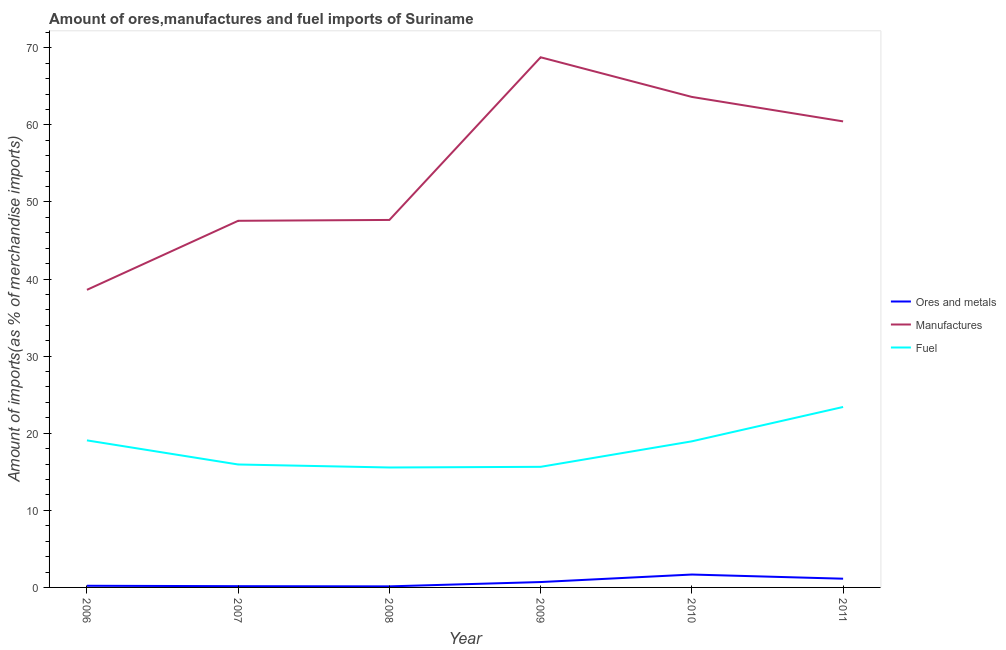Is the number of lines equal to the number of legend labels?
Ensure brevity in your answer.  Yes. What is the percentage of manufactures imports in 2006?
Your response must be concise. 38.6. Across all years, what is the maximum percentage of ores and metals imports?
Offer a very short reply. 1.67. Across all years, what is the minimum percentage of ores and metals imports?
Offer a very short reply. 0.14. In which year was the percentage of manufactures imports maximum?
Provide a succinct answer. 2009. What is the total percentage of ores and metals imports in the graph?
Provide a succinct answer. 4.02. What is the difference between the percentage of fuel imports in 2006 and that in 2007?
Offer a very short reply. 3.13. What is the difference between the percentage of manufactures imports in 2011 and the percentage of fuel imports in 2009?
Provide a succinct answer. 44.81. What is the average percentage of manufactures imports per year?
Your answer should be compact. 54.44. In the year 2009, what is the difference between the percentage of fuel imports and percentage of manufactures imports?
Make the answer very short. -53.12. What is the ratio of the percentage of fuel imports in 2007 to that in 2010?
Offer a terse response. 0.84. Is the percentage of manufactures imports in 2007 less than that in 2009?
Ensure brevity in your answer.  Yes. Is the difference between the percentage of ores and metals imports in 2007 and 2010 greater than the difference between the percentage of manufactures imports in 2007 and 2010?
Make the answer very short. Yes. What is the difference between the highest and the second highest percentage of manufactures imports?
Offer a very short reply. 5.14. What is the difference between the highest and the lowest percentage of ores and metals imports?
Keep it short and to the point. 1.54. In how many years, is the percentage of manufactures imports greater than the average percentage of manufactures imports taken over all years?
Ensure brevity in your answer.  3. Is the sum of the percentage of manufactures imports in 2009 and 2011 greater than the maximum percentage of fuel imports across all years?
Provide a short and direct response. Yes. Is it the case that in every year, the sum of the percentage of ores and metals imports and percentage of manufactures imports is greater than the percentage of fuel imports?
Give a very brief answer. Yes. Is the percentage of manufactures imports strictly greater than the percentage of ores and metals imports over the years?
Offer a terse response. Yes. How many lines are there?
Offer a very short reply. 3. Does the graph contain grids?
Provide a short and direct response. No. How many legend labels are there?
Your answer should be compact. 3. What is the title of the graph?
Ensure brevity in your answer.  Amount of ores,manufactures and fuel imports of Suriname. Does "Primary" appear as one of the legend labels in the graph?
Your answer should be compact. No. What is the label or title of the Y-axis?
Your answer should be very brief. Amount of imports(as % of merchandise imports). What is the Amount of imports(as % of merchandise imports) in Ores and metals in 2006?
Your answer should be very brief. 0.22. What is the Amount of imports(as % of merchandise imports) in Manufactures in 2006?
Ensure brevity in your answer.  38.6. What is the Amount of imports(as % of merchandise imports) of Fuel in 2006?
Your response must be concise. 19.07. What is the Amount of imports(as % of merchandise imports) of Ores and metals in 2007?
Ensure brevity in your answer.  0.16. What is the Amount of imports(as % of merchandise imports) in Manufactures in 2007?
Provide a succinct answer. 47.55. What is the Amount of imports(as % of merchandise imports) in Fuel in 2007?
Your response must be concise. 15.95. What is the Amount of imports(as % of merchandise imports) in Ores and metals in 2008?
Your answer should be very brief. 0.14. What is the Amount of imports(as % of merchandise imports) of Manufactures in 2008?
Your response must be concise. 47.67. What is the Amount of imports(as % of merchandise imports) in Fuel in 2008?
Give a very brief answer. 15.56. What is the Amount of imports(as % of merchandise imports) in Ores and metals in 2009?
Make the answer very short. 0.7. What is the Amount of imports(as % of merchandise imports) of Manufactures in 2009?
Your answer should be very brief. 68.76. What is the Amount of imports(as % of merchandise imports) of Fuel in 2009?
Your answer should be very brief. 15.64. What is the Amount of imports(as % of merchandise imports) of Ores and metals in 2010?
Make the answer very short. 1.67. What is the Amount of imports(as % of merchandise imports) of Manufactures in 2010?
Your answer should be very brief. 63.62. What is the Amount of imports(as % of merchandise imports) in Fuel in 2010?
Your answer should be very brief. 18.95. What is the Amount of imports(as % of merchandise imports) of Ores and metals in 2011?
Your response must be concise. 1.13. What is the Amount of imports(as % of merchandise imports) of Manufactures in 2011?
Your answer should be very brief. 60.45. What is the Amount of imports(as % of merchandise imports) of Fuel in 2011?
Your response must be concise. 23.4. Across all years, what is the maximum Amount of imports(as % of merchandise imports) in Ores and metals?
Ensure brevity in your answer.  1.67. Across all years, what is the maximum Amount of imports(as % of merchandise imports) of Manufactures?
Make the answer very short. 68.76. Across all years, what is the maximum Amount of imports(as % of merchandise imports) of Fuel?
Ensure brevity in your answer.  23.4. Across all years, what is the minimum Amount of imports(as % of merchandise imports) in Ores and metals?
Your answer should be very brief. 0.14. Across all years, what is the minimum Amount of imports(as % of merchandise imports) of Manufactures?
Make the answer very short. 38.6. Across all years, what is the minimum Amount of imports(as % of merchandise imports) of Fuel?
Ensure brevity in your answer.  15.56. What is the total Amount of imports(as % of merchandise imports) of Ores and metals in the graph?
Offer a very short reply. 4.02. What is the total Amount of imports(as % of merchandise imports) in Manufactures in the graph?
Your response must be concise. 326.65. What is the total Amount of imports(as % of merchandise imports) in Fuel in the graph?
Offer a terse response. 108.57. What is the difference between the Amount of imports(as % of merchandise imports) of Ores and metals in 2006 and that in 2007?
Provide a short and direct response. 0.05. What is the difference between the Amount of imports(as % of merchandise imports) in Manufactures in 2006 and that in 2007?
Keep it short and to the point. -8.95. What is the difference between the Amount of imports(as % of merchandise imports) of Fuel in 2006 and that in 2007?
Your response must be concise. 3.13. What is the difference between the Amount of imports(as % of merchandise imports) of Ores and metals in 2006 and that in 2008?
Your answer should be very brief. 0.08. What is the difference between the Amount of imports(as % of merchandise imports) in Manufactures in 2006 and that in 2008?
Give a very brief answer. -9.07. What is the difference between the Amount of imports(as % of merchandise imports) of Fuel in 2006 and that in 2008?
Make the answer very short. 3.52. What is the difference between the Amount of imports(as % of merchandise imports) of Ores and metals in 2006 and that in 2009?
Offer a terse response. -0.48. What is the difference between the Amount of imports(as % of merchandise imports) in Manufactures in 2006 and that in 2009?
Ensure brevity in your answer.  -30.16. What is the difference between the Amount of imports(as % of merchandise imports) in Fuel in 2006 and that in 2009?
Offer a very short reply. 3.43. What is the difference between the Amount of imports(as % of merchandise imports) in Ores and metals in 2006 and that in 2010?
Make the answer very short. -1.46. What is the difference between the Amount of imports(as % of merchandise imports) of Manufactures in 2006 and that in 2010?
Your response must be concise. -25.02. What is the difference between the Amount of imports(as % of merchandise imports) in Fuel in 2006 and that in 2010?
Your answer should be compact. 0.12. What is the difference between the Amount of imports(as % of merchandise imports) in Ores and metals in 2006 and that in 2011?
Your response must be concise. -0.91. What is the difference between the Amount of imports(as % of merchandise imports) of Manufactures in 2006 and that in 2011?
Your answer should be compact. -21.85. What is the difference between the Amount of imports(as % of merchandise imports) in Fuel in 2006 and that in 2011?
Provide a succinct answer. -4.33. What is the difference between the Amount of imports(as % of merchandise imports) of Ores and metals in 2007 and that in 2008?
Your response must be concise. 0.03. What is the difference between the Amount of imports(as % of merchandise imports) of Manufactures in 2007 and that in 2008?
Offer a very short reply. -0.11. What is the difference between the Amount of imports(as % of merchandise imports) of Fuel in 2007 and that in 2008?
Provide a short and direct response. 0.39. What is the difference between the Amount of imports(as % of merchandise imports) of Ores and metals in 2007 and that in 2009?
Provide a succinct answer. -0.53. What is the difference between the Amount of imports(as % of merchandise imports) of Manufactures in 2007 and that in 2009?
Provide a short and direct response. -21.21. What is the difference between the Amount of imports(as % of merchandise imports) in Fuel in 2007 and that in 2009?
Provide a short and direct response. 0.3. What is the difference between the Amount of imports(as % of merchandise imports) of Ores and metals in 2007 and that in 2010?
Provide a short and direct response. -1.51. What is the difference between the Amount of imports(as % of merchandise imports) in Manufactures in 2007 and that in 2010?
Offer a terse response. -16.07. What is the difference between the Amount of imports(as % of merchandise imports) in Fuel in 2007 and that in 2010?
Offer a terse response. -3. What is the difference between the Amount of imports(as % of merchandise imports) of Ores and metals in 2007 and that in 2011?
Offer a very short reply. -0.97. What is the difference between the Amount of imports(as % of merchandise imports) of Manufactures in 2007 and that in 2011?
Your answer should be very brief. -12.89. What is the difference between the Amount of imports(as % of merchandise imports) of Fuel in 2007 and that in 2011?
Provide a short and direct response. -7.46. What is the difference between the Amount of imports(as % of merchandise imports) in Ores and metals in 2008 and that in 2009?
Ensure brevity in your answer.  -0.56. What is the difference between the Amount of imports(as % of merchandise imports) in Manufactures in 2008 and that in 2009?
Ensure brevity in your answer.  -21.1. What is the difference between the Amount of imports(as % of merchandise imports) of Fuel in 2008 and that in 2009?
Ensure brevity in your answer.  -0.09. What is the difference between the Amount of imports(as % of merchandise imports) of Ores and metals in 2008 and that in 2010?
Provide a short and direct response. -1.54. What is the difference between the Amount of imports(as % of merchandise imports) in Manufactures in 2008 and that in 2010?
Offer a terse response. -15.96. What is the difference between the Amount of imports(as % of merchandise imports) of Fuel in 2008 and that in 2010?
Your response must be concise. -3.39. What is the difference between the Amount of imports(as % of merchandise imports) in Ores and metals in 2008 and that in 2011?
Provide a short and direct response. -0.99. What is the difference between the Amount of imports(as % of merchandise imports) of Manufactures in 2008 and that in 2011?
Make the answer very short. -12.78. What is the difference between the Amount of imports(as % of merchandise imports) of Fuel in 2008 and that in 2011?
Give a very brief answer. -7.85. What is the difference between the Amount of imports(as % of merchandise imports) of Ores and metals in 2009 and that in 2010?
Your answer should be compact. -0.98. What is the difference between the Amount of imports(as % of merchandise imports) in Manufactures in 2009 and that in 2010?
Your answer should be very brief. 5.14. What is the difference between the Amount of imports(as % of merchandise imports) of Fuel in 2009 and that in 2010?
Provide a short and direct response. -3.31. What is the difference between the Amount of imports(as % of merchandise imports) in Ores and metals in 2009 and that in 2011?
Keep it short and to the point. -0.43. What is the difference between the Amount of imports(as % of merchandise imports) of Manufactures in 2009 and that in 2011?
Offer a very short reply. 8.32. What is the difference between the Amount of imports(as % of merchandise imports) of Fuel in 2009 and that in 2011?
Your answer should be very brief. -7.76. What is the difference between the Amount of imports(as % of merchandise imports) of Ores and metals in 2010 and that in 2011?
Ensure brevity in your answer.  0.54. What is the difference between the Amount of imports(as % of merchandise imports) in Manufactures in 2010 and that in 2011?
Provide a succinct answer. 3.17. What is the difference between the Amount of imports(as % of merchandise imports) of Fuel in 2010 and that in 2011?
Your answer should be compact. -4.45. What is the difference between the Amount of imports(as % of merchandise imports) of Ores and metals in 2006 and the Amount of imports(as % of merchandise imports) of Manufactures in 2007?
Your answer should be very brief. -47.34. What is the difference between the Amount of imports(as % of merchandise imports) in Ores and metals in 2006 and the Amount of imports(as % of merchandise imports) in Fuel in 2007?
Make the answer very short. -15.73. What is the difference between the Amount of imports(as % of merchandise imports) of Manufactures in 2006 and the Amount of imports(as % of merchandise imports) of Fuel in 2007?
Give a very brief answer. 22.65. What is the difference between the Amount of imports(as % of merchandise imports) of Ores and metals in 2006 and the Amount of imports(as % of merchandise imports) of Manufactures in 2008?
Provide a short and direct response. -47.45. What is the difference between the Amount of imports(as % of merchandise imports) of Ores and metals in 2006 and the Amount of imports(as % of merchandise imports) of Fuel in 2008?
Ensure brevity in your answer.  -15.34. What is the difference between the Amount of imports(as % of merchandise imports) of Manufactures in 2006 and the Amount of imports(as % of merchandise imports) of Fuel in 2008?
Your answer should be compact. 23.04. What is the difference between the Amount of imports(as % of merchandise imports) in Ores and metals in 2006 and the Amount of imports(as % of merchandise imports) in Manufactures in 2009?
Ensure brevity in your answer.  -68.55. What is the difference between the Amount of imports(as % of merchandise imports) in Ores and metals in 2006 and the Amount of imports(as % of merchandise imports) in Fuel in 2009?
Your answer should be very brief. -15.43. What is the difference between the Amount of imports(as % of merchandise imports) in Manufactures in 2006 and the Amount of imports(as % of merchandise imports) in Fuel in 2009?
Offer a very short reply. 22.96. What is the difference between the Amount of imports(as % of merchandise imports) of Ores and metals in 2006 and the Amount of imports(as % of merchandise imports) of Manufactures in 2010?
Keep it short and to the point. -63.4. What is the difference between the Amount of imports(as % of merchandise imports) of Ores and metals in 2006 and the Amount of imports(as % of merchandise imports) of Fuel in 2010?
Provide a short and direct response. -18.73. What is the difference between the Amount of imports(as % of merchandise imports) of Manufactures in 2006 and the Amount of imports(as % of merchandise imports) of Fuel in 2010?
Your answer should be very brief. 19.65. What is the difference between the Amount of imports(as % of merchandise imports) of Ores and metals in 2006 and the Amount of imports(as % of merchandise imports) of Manufactures in 2011?
Offer a very short reply. -60.23. What is the difference between the Amount of imports(as % of merchandise imports) in Ores and metals in 2006 and the Amount of imports(as % of merchandise imports) in Fuel in 2011?
Make the answer very short. -23.19. What is the difference between the Amount of imports(as % of merchandise imports) of Manufactures in 2006 and the Amount of imports(as % of merchandise imports) of Fuel in 2011?
Your answer should be compact. 15.2. What is the difference between the Amount of imports(as % of merchandise imports) in Ores and metals in 2007 and the Amount of imports(as % of merchandise imports) in Manufactures in 2008?
Provide a short and direct response. -47.5. What is the difference between the Amount of imports(as % of merchandise imports) in Ores and metals in 2007 and the Amount of imports(as % of merchandise imports) in Fuel in 2008?
Make the answer very short. -15.39. What is the difference between the Amount of imports(as % of merchandise imports) in Manufactures in 2007 and the Amount of imports(as % of merchandise imports) in Fuel in 2008?
Your answer should be compact. 32. What is the difference between the Amount of imports(as % of merchandise imports) of Ores and metals in 2007 and the Amount of imports(as % of merchandise imports) of Manufactures in 2009?
Make the answer very short. -68.6. What is the difference between the Amount of imports(as % of merchandise imports) of Ores and metals in 2007 and the Amount of imports(as % of merchandise imports) of Fuel in 2009?
Provide a succinct answer. -15.48. What is the difference between the Amount of imports(as % of merchandise imports) of Manufactures in 2007 and the Amount of imports(as % of merchandise imports) of Fuel in 2009?
Offer a very short reply. 31.91. What is the difference between the Amount of imports(as % of merchandise imports) in Ores and metals in 2007 and the Amount of imports(as % of merchandise imports) in Manufactures in 2010?
Make the answer very short. -63.46. What is the difference between the Amount of imports(as % of merchandise imports) of Ores and metals in 2007 and the Amount of imports(as % of merchandise imports) of Fuel in 2010?
Provide a succinct answer. -18.79. What is the difference between the Amount of imports(as % of merchandise imports) in Manufactures in 2007 and the Amount of imports(as % of merchandise imports) in Fuel in 2010?
Give a very brief answer. 28.6. What is the difference between the Amount of imports(as % of merchandise imports) in Ores and metals in 2007 and the Amount of imports(as % of merchandise imports) in Manufactures in 2011?
Your answer should be compact. -60.28. What is the difference between the Amount of imports(as % of merchandise imports) in Ores and metals in 2007 and the Amount of imports(as % of merchandise imports) in Fuel in 2011?
Offer a very short reply. -23.24. What is the difference between the Amount of imports(as % of merchandise imports) in Manufactures in 2007 and the Amount of imports(as % of merchandise imports) in Fuel in 2011?
Ensure brevity in your answer.  24.15. What is the difference between the Amount of imports(as % of merchandise imports) in Ores and metals in 2008 and the Amount of imports(as % of merchandise imports) in Manufactures in 2009?
Your response must be concise. -68.63. What is the difference between the Amount of imports(as % of merchandise imports) of Ores and metals in 2008 and the Amount of imports(as % of merchandise imports) of Fuel in 2009?
Offer a very short reply. -15.5. What is the difference between the Amount of imports(as % of merchandise imports) of Manufactures in 2008 and the Amount of imports(as % of merchandise imports) of Fuel in 2009?
Your response must be concise. 32.02. What is the difference between the Amount of imports(as % of merchandise imports) in Ores and metals in 2008 and the Amount of imports(as % of merchandise imports) in Manufactures in 2010?
Offer a very short reply. -63.48. What is the difference between the Amount of imports(as % of merchandise imports) in Ores and metals in 2008 and the Amount of imports(as % of merchandise imports) in Fuel in 2010?
Give a very brief answer. -18.81. What is the difference between the Amount of imports(as % of merchandise imports) in Manufactures in 2008 and the Amount of imports(as % of merchandise imports) in Fuel in 2010?
Ensure brevity in your answer.  28.71. What is the difference between the Amount of imports(as % of merchandise imports) in Ores and metals in 2008 and the Amount of imports(as % of merchandise imports) in Manufactures in 2011?
Offer a terse response. -60.31. What is the difference between the Amount of imports(as % of merchandise imports) of Ores and metals in 2008 and the Amount of imports(as % of merchandise imports) of Fuel in 2011?
Keep it short and to the point. -23.27. What is the difference between the Amount of imports(as % of merchandise imports) in Manufactures in 2008 and the Amount of imports(as % of merchandise imports) in Fuel in 2011?
Your answer should be compact. 24.26. What is the difference between the Amount of imports(as % of merchandise imports) of Ores and metals in 2009 and the Amount of imports(as % of merchandise imports) of Manufactures in 2010?
Your response must be concise. -62.92. What is the difference between the Amount of imports(as % of merchandise imports) of Ores and metals in 2009 and the Amount of imports(as % of merchandise imports) of Fuel in 2010?
Your response must be concise. -18.25. What is the difference between the Amount of imports(as % of merchandise imports) of Manufactures in 2009 and the Amount of imports(as % of merchandise imports) of Fuel in 2010?
Provide a short and direct response. 49.81. What is the difference between the Amount of imports(as % of merchandise imports) of Ores and metals in 2009 and the Amount of imports(as % of merchandise imports) of Manufactures in 2011?
Make the answer very short. -59.75. What is the difference between the Amount of imports(as % of merchandise imports) of Ores and metals in 2009 and the Amount of imports(as % of merchandise imports) of Fuel in 2011?
Ensure brevity in your answer.  -22.71. What is the difference between the Amount of imports(as % of merchandise imports) of Manufactures in 2009 and the Amount of imports(as % of merchandise imports) of Fuel in 2011?
Ensure brevity in your answer.  45.36. What is the difference between the Amount of imports(as % of merchandise imports) in Ores and metals in 2010 and the Amount of imports(as % of merchandise imports) in Manufactures in 2011?
Provide a succinct answer. -58.78. What is the difference between the Amount of imports(as % of merchandise imports) of Ores and metals in 2010 and the Amount of imports(as % of merchandise imports) of Fuel in 2011?
Your response must be concise. -21.73. What is the difference between the Amount of imports(as % of merchandise imports) of Manufactures in 2010 and the Amount of imports(as % of merchandise imports) of Fuel in 2011?
Make the answer very short. 40.22. What is the average Amount of imports(as % of merchandise imports) of Ores and metals per year?
Keep it short and to the point. 0.67. What is the average Amount of imports(as % of merchandise imports) in Manufactures per year?
Your response must be concise. 54.44. What is the average Amount of imports(as % of merchandise imports) in Fuel per year?
Offer a terse response. 18.1. In the year 2006, what is the difference between the Amount of imports(as % of merchandise imports) of Ores and metals and Amount of imports(as % of merchandise imports) of Manufactures?
Make the answer very short. -38.38. In the year 2006, what is the difference between the Amount of imports(as % of merchandise imports) in Ores and metals and Amount of imports(as % of merchandise imports) in Fuel?
Keep it short and to the point. -18.86. In the year 2006, what is the difference between the Amount of imports(as % of merchandise imports) of Manufactures and Amount of imports(as % of merchandise imports) of Fuel?
Your answer should be very brief. 19.53. In the year 2007, what is the difference between the Amount of imports(as % of merchandise imports) in Ores and metals and Amount of imports(as % of merchandise imports) in Manufactures?
Make the answer very short. -47.39. In the year 2007, what is the difference between the Amount of imports(as % of merchandise imports) of Ores and metals and Amount of imports(as % of merchandise imports) of Fuel?
Your answer should be very brief. -15.78. In the year 2007, what is the difference between the Amount of imports(as % of merchandise imports) of Manufactures and Amount of imports(as % of merchandise imports) of Fuel?
Provide a short and direct response. 31.61. In the year 2008, what is the difference between the Amount of imports(as % of merchandise imports) of Ores and metals and Amount of imports(as % of merchandise imports) of Manufactures?
Ensure brevity in your answer.  -47.53. In the year 2008, what is the difference between the Amount of imports(as % of merchandise imports) of Ores and metals and Amount of imports(as % of merchandise imports) of Fuel?
Make the answer very short. -15.42. In the year 2008, what is the difference between the Amount of imports(as % of merchandise imports) of Manufactures and Amount of imports(as % of merchandise imports) of Fuel?
Ensure brevity in your answer.  32.11. In the year 2009, what is the difference between the Amount of imports(as % of merchandise imports) in Ores and metals and Amount of imports(as % of merchandise imports) in Manufactures?
Ensure brevity in your answer.  -68.07. In the year 2009, what is the difference between the Amount of imports(as % of merchandise imports) of Ores and metals and Amount of imports(as % of merchandise imports) of Fuel?
Provide a short and direct response. -14.94. In the year 2009, what is the difference between the Amount of imports(as % of merchandise imports) in Manufactures and Amount of imports(as % of merchandise imports) in Fuel?
Give a very brief answer. 53.12. In the year 2010, what is the difference between the Amount of imports(as % of merchandise imports) in Ores and metals and Amount of imports(as % of merchandise imports) in Manufactures?
Give a very brief answer. -61.95. In the year 2010, what is the difference between the Amount of imports(as % of merchandise imports) in Ores and metals and Amount of imports(as % of merchandise imports) in Fuel?
Give a very brief answer. -17.28. In the year 2010, what is the difference between the Amount of imports(as % of merchandise imports) in Manufactures and Amount of imports(as % of merchandise imports) in Fuel?
Ensure brevity in your answer.  44.67. In the year 2011, what is the difference between the Amount of imports(as % of merchandise imports) in Ores and metals and Amount of imports(as % of merchandise imports) in Manufactures?
Provide a short and direct response. -59.32. In the year 2011, what is the difference between the Amount of imports(as % of merchandise imports) of Ores and metals and Amount of imports(as % of merchandise imports) of Fuel?
Offer a terse response. -22.27. In the year 2011, what is the difference between the Amount of imports(as % of merchandise imports) in Manufactures and Amount of imports(as % of merchandise imports) in Fuel?
Your response must be concise. 37.04. What is the ratio of the Amount of imports(as % of merchandise imports) in Ores and metals in 2006 to that in 2007?
Offer a very short reply. 1.33. What is the ratio of the Amount of imports(as % of merchandise imports) in Manufactures in 2006 to that in 2007?
Provide a short and direct response. 0.81. What is the ratio of the Amount of imports(as % of merchandise imports) of Fuel in 2006 to that in 2007?
Give a very brief answer. 1.2. What is the ratio of the Amount of imports(as % of merchandise imports) of Ores and metals in 2006 to that in 2008?
Offer a very short reply. 1.57. What is the ratio of the Amount of imports(as % of merchandise imports) in Manufactures in 2006 to that in 2008?
Keep it short and to the point. 0.81. What is the ratio of the Amount of imports(as % of merchandise imports) in Fuel in 2006 to that in 2008?
Your response must be concise. 1.23. What is the ratio of the Amount of imports(as % of merchandise imports) in Ores and metals in 2006 to that in 2009?
Ensure brevity in your answer.  0.31. What is the ratio of the Amount of imports(as % of merchandise imports) of Manufactures in 2006 to that in 2009?
Offer a terse response. 0.56. What is the ratio of the Amount of imports(as % of merchandise imports) in Fuel in 2006 to that in 2009?
Offer a very short reply. 1.22. What is the ratio of the Amount of imports(as % of merchandise imports) of Ores and metals in 2006 to that in 2010?
Make the answer very short. 0.13. What is the ratio of the Amount of imports(as % of merchandise imports) of Manufactures in 2006 to that in 2010?
Make the answer very short. 0.61. What is the ratio of the Amount of imports(as % of merchandise imports) of Fuel in 2006 to that in 2010?
Your response must be concise. 1.01. What is the ratio of the Amount of imports(as % of merchandise imports) of Ores and metals in 2006 to that in 2011?
Ensure brevity in your answer.  0.19. What is the ratio of the Amount of imports(as % of merchandise imports) of Manufactures in 2006 to that in 2011?
Give a very brief answer. 0.64. What is the ratio of the Amount of imports(as % of merchandise imports) in Fuel in 2006 to that in 2011?
Provide a short and direct response. 0.81. What is the ratio of the Amount of imports(as % of merchandise imports) of Ores and metals in 2007 to that in 2008?
Provide a short and direct response. 1.19. What is the ratio of the Amount of imports(as % of merchandise imports) in Fuel in 2007 to that in 2008?
Provide a short and direct response. 1.02. What is the ratio of the Amount of imports(as % of merchandise imports) of Ores and metals in 2007 to that in 2009?
Make the answer very short. 0.23. What is the ratio of the Amount of imports(as % of merchandise imports) in Manufactures in 2007 to that in 2009?
Your answer should be very brief. 0.69. What is the ratio of the Amount of imports(as % of merchandise imports) in Fuel in 2007 to that in 2009?
Offer a terse response. 1.02. What is the ratio of the Amount of imports(as % of merchandise imports) in Ores and metals in 2007 to that in 2010?
Provide a short and direct response. 0.1. What is the ratio of the Amount of imports(as % of merchandise imports) in Manufactures in 2007 to that in 2010?
Your answer should be very brief. 0.75. What is the ratio of the Amount of imports(as % of merchandise imports) in Fuel in 2007 to that in 2010?
Your answer should be very brief. 0.84. What is the ratio of the Amount of imports(as % of merchandise imports) of Ores and metals in 2007 to that in 2011?
Make the answer very short. 0.14. What is the ratio of the Amount of imports(as % of merchandise imports) in Manufactures in 2007 to that in 2011?
Your response must be concise. 0.79. What is the ratio of the Amount of imports(as % of merchandise imports) in Fuel in 2007 to that in 2011?
Your answer should be compact. 0.68. What is the ratio of the Amount of imports(as % of merchandise imports) of Ores and metals in 2008 to that in 2009?
Your response must be concise. 0.2. What is the ratio of the Amount of imports(as % of merchandise imports) in Manufactures in 2008 to that in 2009?
Ensure brevity in your answer.  0.69. What is the ratio of the Amount of imports(as % of merchandise imports) of Fuel in 2008 to that in 2009?
Your answer should be very brief. 0.99. What is the ratio of the Amount of imports(as % of merchandise imports) of Ores and metals in 2008 to that in 2010?
Ensure brevity in your answer.  0.08. What is the ratio of the Amount of imports(as % of merchandise imports) in Manufactures in 2008 to that in 2010?
Your answer should be compact. 0.75. What is the ratio of the Amount of imports(as % of merchandise imports) of Fuel in 2008 to that in 2010?
Offer a terse response. 0.82. What is the ratio of the Amount of imports(as % of merchandise imports) in Ores and metals in 2008 to that in 2011?
Keep it short and to the point. 0.12. What is the ratio of the Amount of imports(as % of merchandise imports) in Manufactures in 2008 to that in 2011?
Offer a terse response. 0.79. What is the ratio of the Amount of imports(as % of merchandise imports) in Fuel in 2008 to that in 2011?
Provide a short and direct response. 0.66. What is the ratio of the Amount of imports(as % of merchandise imports) of Ores and metals in 2009 to that in 2010?
Provide a short and direct response. 0.42. What is the ratio of the Amount of imports(as % of merchandise imports) in Manufactures in 2009 to that in 2010?
Ensure brevity in your answer.  1.08. What is the ratio of the Amount of imports(as % of merchandise imports) of Fuel in 2009 to that in 2010?
Give a very brief answer. 0.83. What is the ratio of the Amount of imports(as % of merchandise imports) in Ores and metals in 2009 to that in 2011?
Provide a succinct answer. 0.62. What is the ratio of the Amount of imports(as % of merchandise imports) of Manufactures in 2009 to that in 2011?
Give a very brief answer. 1.14. What is the ratio of the Amount of imports(as % of merchandise imports) in Fuel in 2009 to that in 2011?
Make the answer very short. 0.67. What is the ratio of the Amount of imports(as % of merchandise imports) of Ores and metals in 2010 to that in 2011?
Your response must be concise. 1.48. What is the ratio of the Amount of imports(as % of merchandise imports) of Manufactures in 2010 to that in 2011?
Offer a terse response. 1.05. What is the ratio of the Amount of imports(as % of merchandise imports) of Fuel in 2010 to that in 2011?
Your answer should be compact. 0.81. What is the difference between the highest and the second highest Amount of imports(as % of merchandise imports) in Ores and metals?
Give a very brief answer. 0.54. What is the difference between the highest and the second highest Amount of imports(as % of merchandise imports) of Manufactures?
Offer a terse response. 5.14. What is the difference between the highest and the second highest Amount of imports(as % of merchandise imports) of Fuel?
Your answer should be very brief. 4.33. What is the difference between the highest and the lowest Amount of imports(as % of merchandise imports) of Ores and metals?
Make the answer very short. 1.54. What is the difference between the highest and the lowest Amount of imports(as % of merchandise imports) of Manufactures?
Your response must be concise. 30.16. What is the difference between the highest and the lowest Amount of imports(as % of merchandise imports) of Fuel?
Provide a succinct answer. 7.85. 